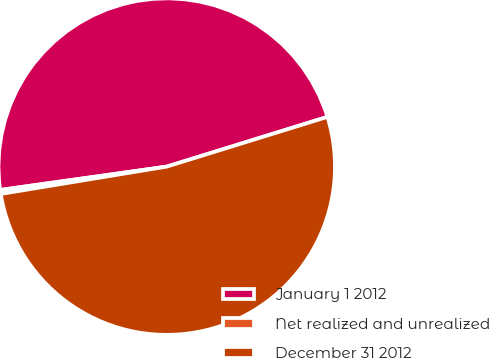<chart> <loc_0><loc_0><loc_500><loc_500><pie_chart><fcel>January 1 2012<fcel>Net realized and unrealized<fcel>December 31 2012<nl><fcel>47.44%<fcel>0.38%<fcel>52.18%<nl></chart> 